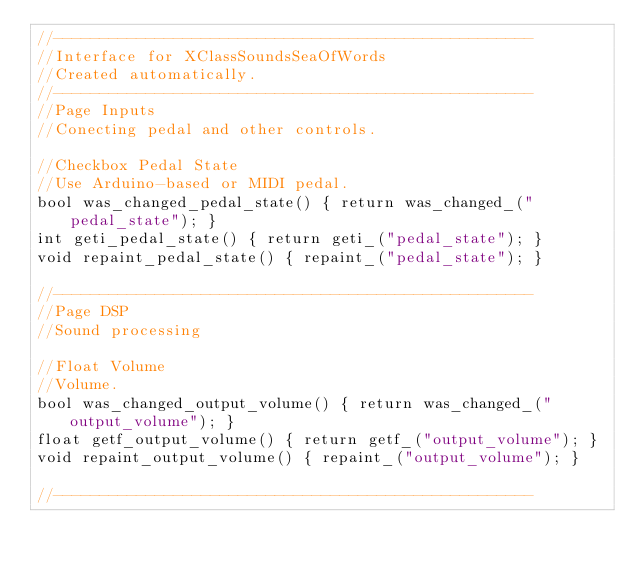Convert code to text. <code><loc_0><loc_0><loc_500><loc_500><_C_>//----------------------------------------------------
//Interface for XClassSoundsSeaOfWords
//Created automatically.
//----------------------------------------------------
//Page Inputs
//Conecting pedal and other controls.

//Checkbox Pedal State
//Use Arduino-based or MIDI pedal.
bool was_changed_pedal_state() { return was_changed_("pedal_state"); }
int geti_pedal_state() { return geti_("pedal_state"); }
void repaint_pedal_state() { repaint_("pedal_state"); }

//----------------------------------------------------
//Page DSP
//Sound processing

//Float Volume
//Volume.
bool was_changed_output_volume() { return was_changed_("output_volume"); }
float getf_output_volume() { return getf_("output_volume"); }
void repaint_output_volume() { repaint_("output_volume"); }

//----------------------------------------------------
</code> 